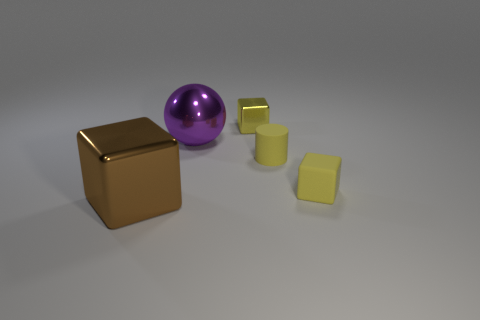Add 1 spheres. How many objects exist? 6 Subtract all cylinders. How many objects are left? 4 Subtract all yellow matte cubes. Subtract all small yellow matte blocks. How many objects are left? 3 Add 4 large purple shiny things. How many large purple shiny things are left? 5 Add 2 rubber cubes. How many rubber cubes exist? 3 Subtract 1 purple spheres. How many objects are left? 4 